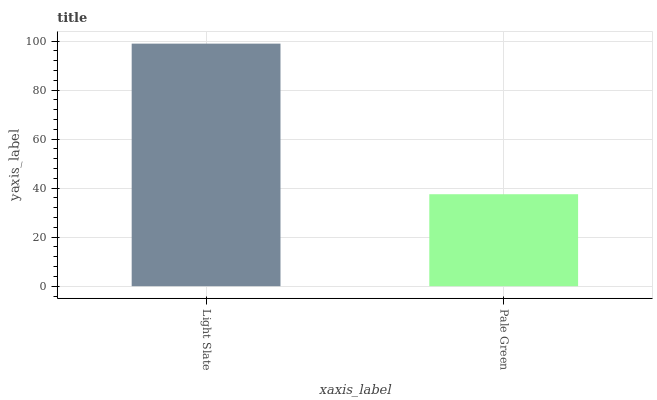Is Pale Green the maximum?
Answer yes or no. No. Is Light Slate greater than Pale Green?
Answer yes or no. Yes. Is Pale Green less than Light Slate?
Answer yes or no. Yes. Is Pale Green greater than Light Slate?
Answer yes or no. No. Is Light Slate less than Pale Green?
Answer yes or no. No. Is Light Slate the high median?
Answer yes or no. Yes. Is Pale Green the low median?
Answer yes or no. Yes. Is Pale Green the high median?
Answer yes or no. No. Is Light Slate the low median?
Answer yes or no. No. 